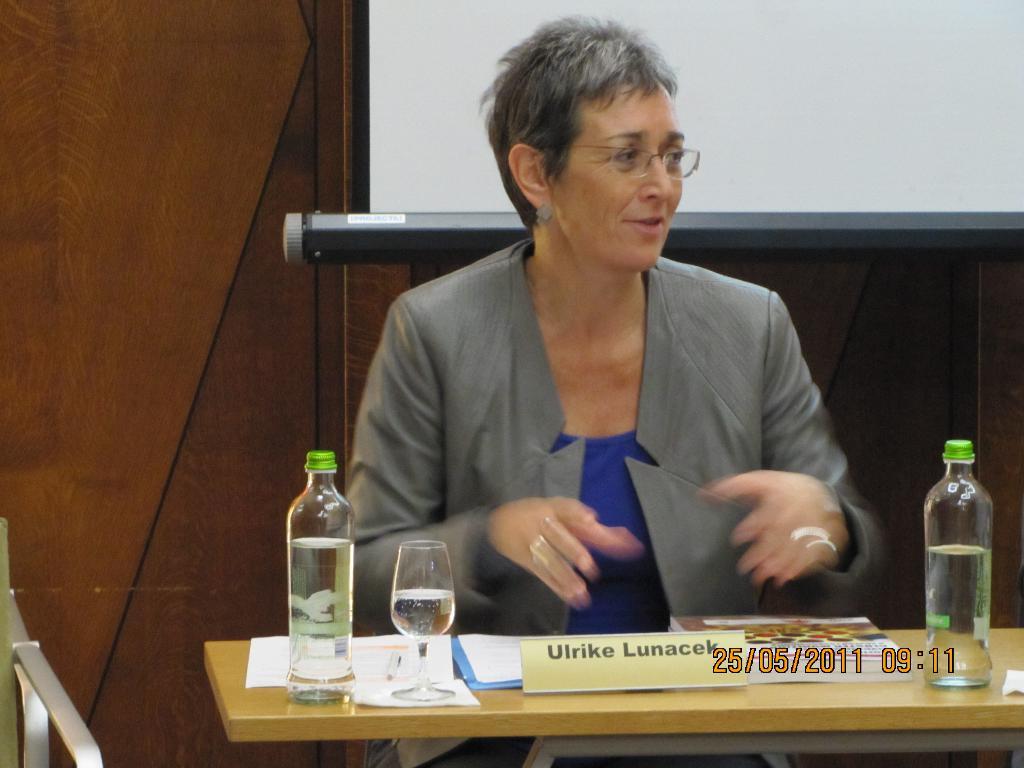What is this woman's name?
Provide a succinct answer. Ulrike lunacek. How many bottles are there?
Offer a terse response. Answering does not require reading text in the image. 